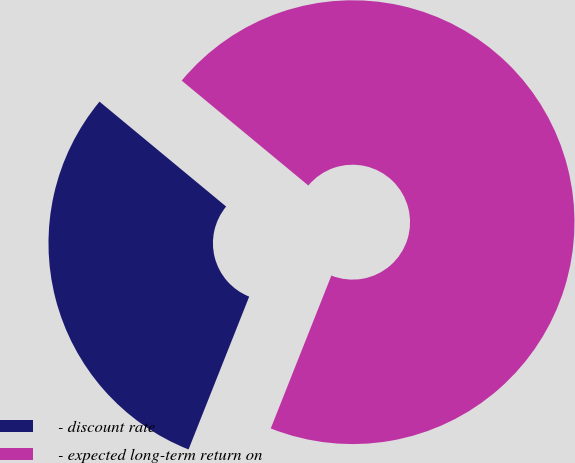<chart> <loc_0><loc_0><loc_500><loc_500><pie_chart><fcel>- discount rate<fcel>- expected long-term return on<nl><fcel>30.0%<fcel>70.0%<nl></chart> 